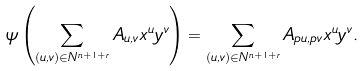Convert formula to latex. <formula><loc_0><loc_0><loc_500><loc_500>\psi \left ( \sum _ { ( u , v ) \in { N } ^ { n + 1 + r } } A _ { u , v } x ^ { u } y ^ { v } \right ) = \sum _ { ( u , v ) \in { N } ^ { n + 1 + r } } A _ { p u , p v } x ^ { u } y ^ { v } .</formula> 